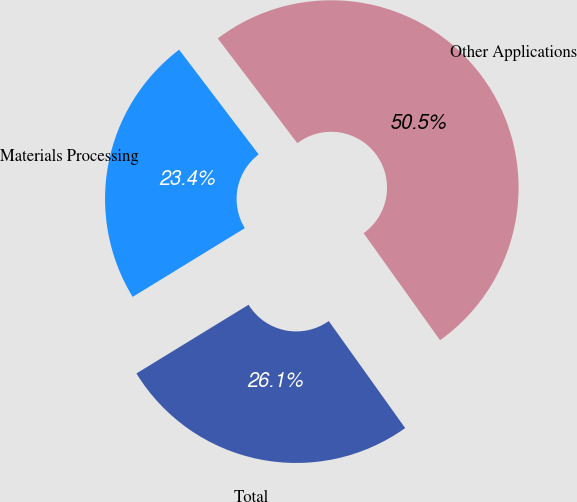Convert chart to OTSL. <chart><loc_0><loc_0><loc_500><loc_500><pie_chart><fcel>Materials Processing<fcel>Other Applications<fcel>Total<nl><fcel>23.41%<fcel>50.47%<fcel>26.12%<nl></chart> 